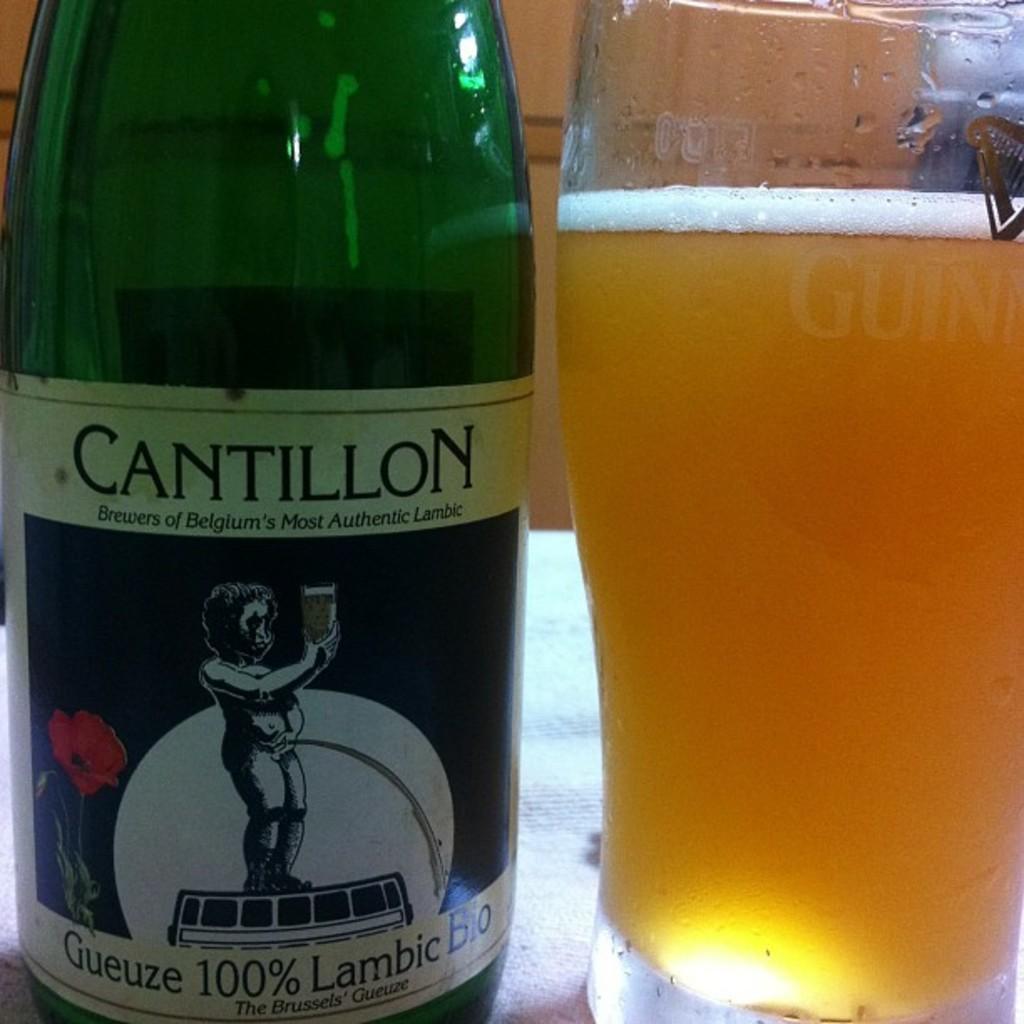What is the drinks brand name?
Provide a short and direct response. Cantillon. Is this 100% lambic?
Your answer should be compact. Yes. 